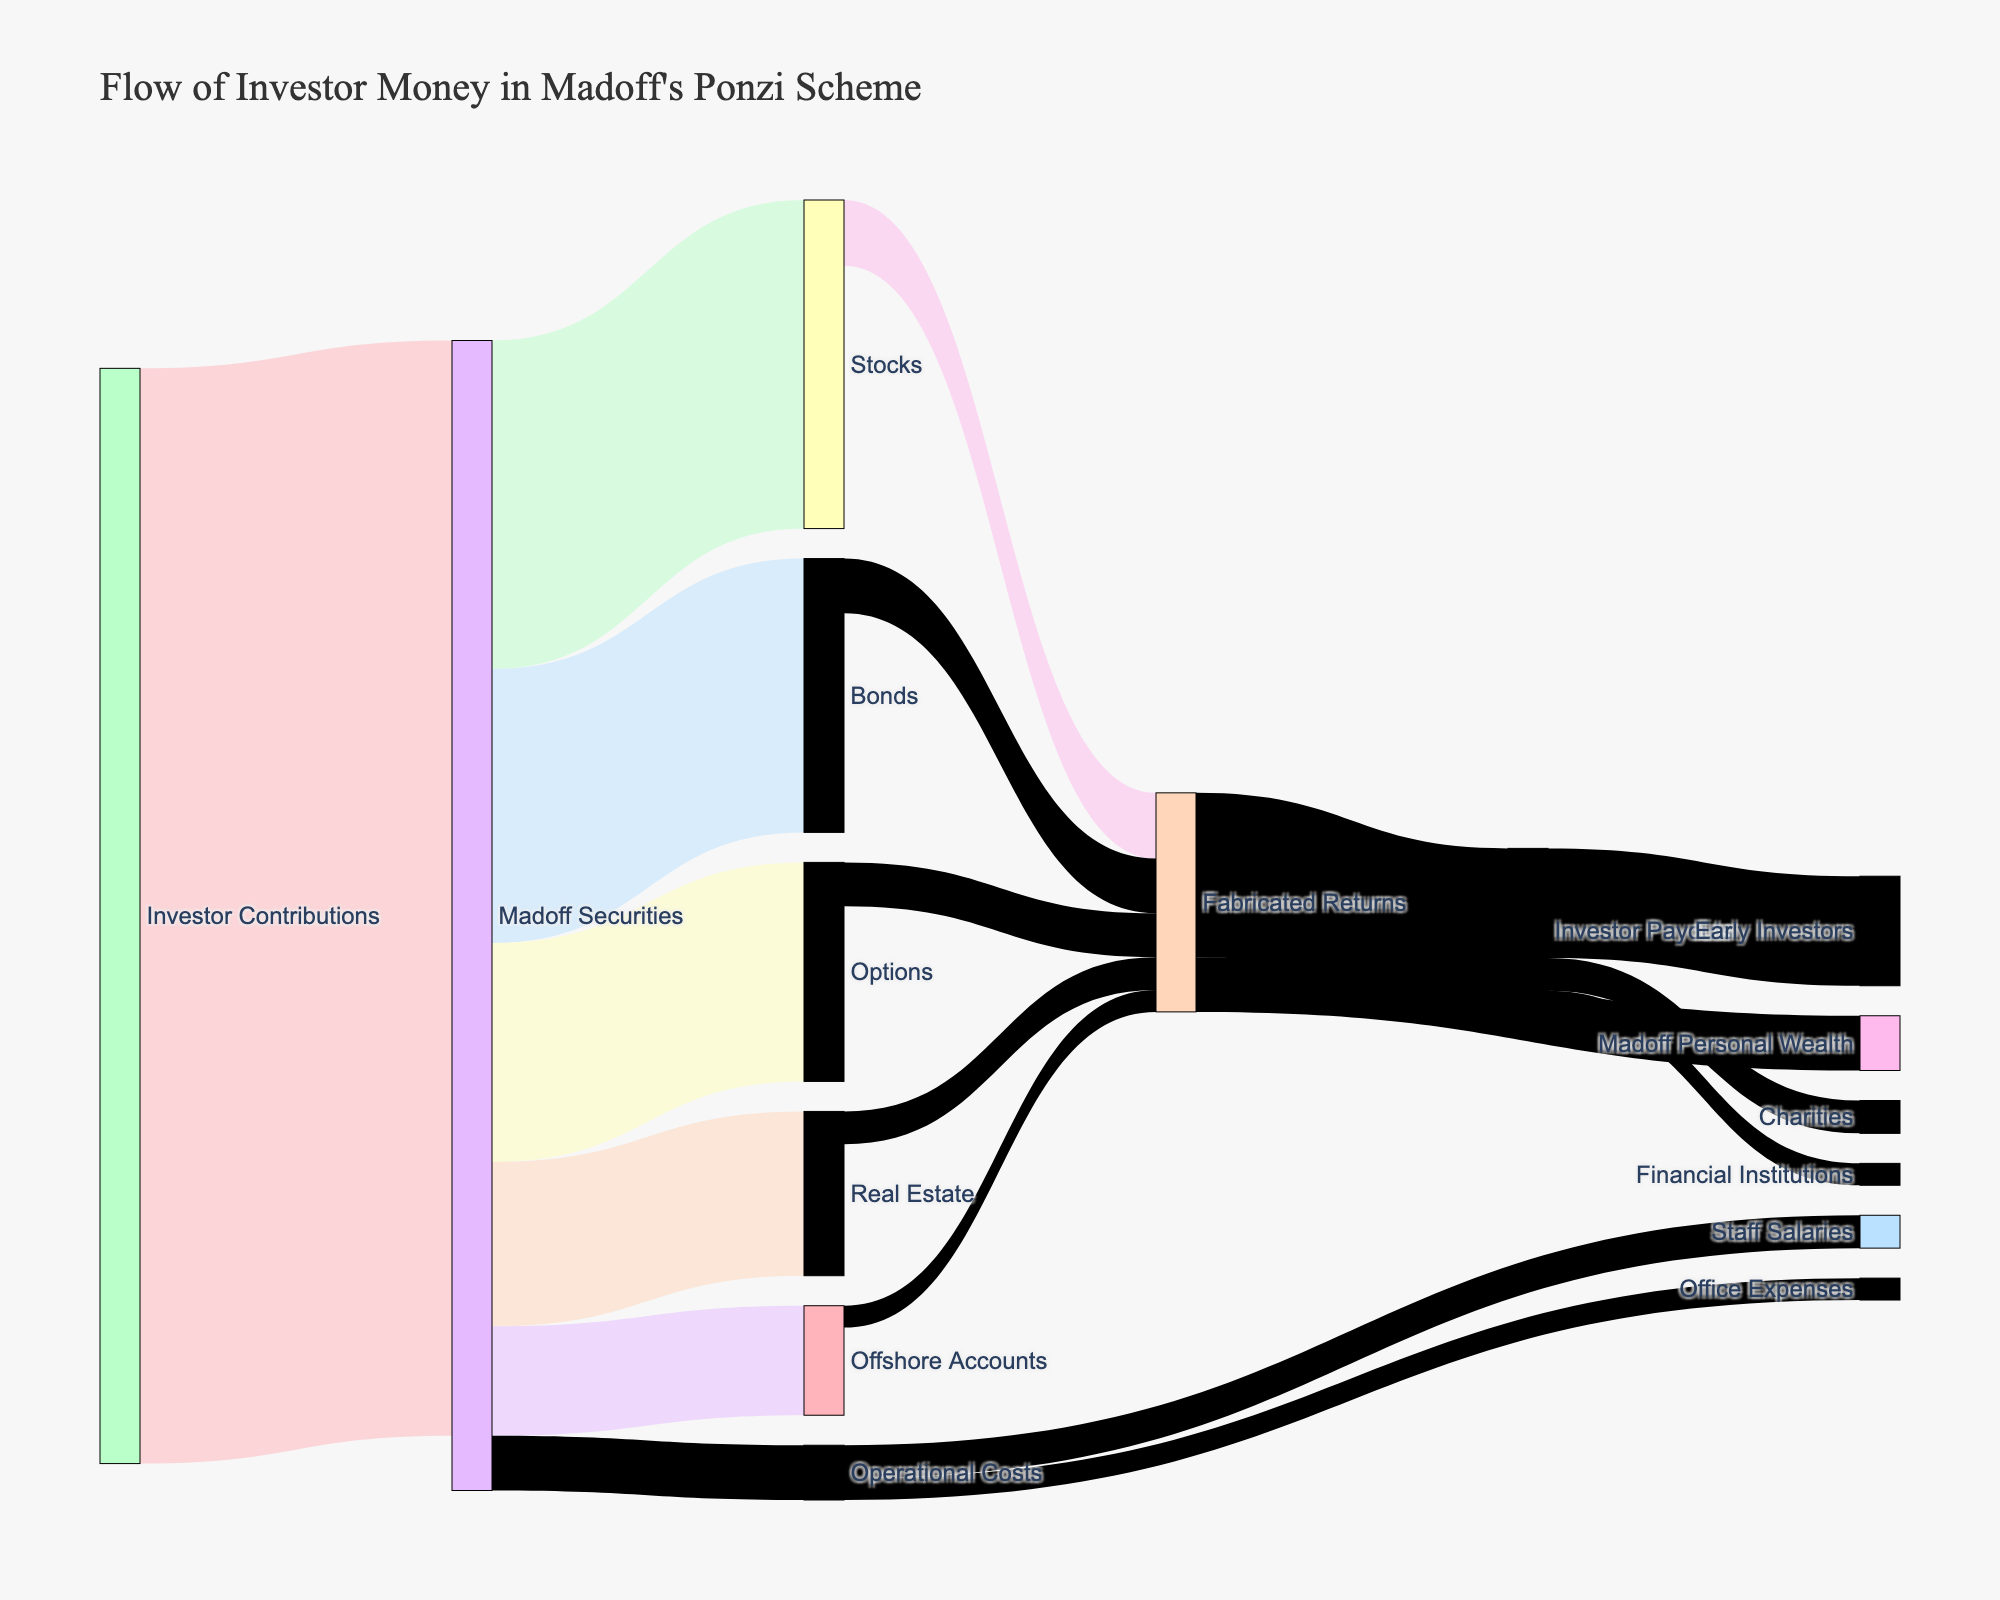What is the main title of the diagram? The main title is typically located at the top center of the figure. The title for this diagram reads "Flow of Investor Money in Madoff's Ponzi Scheme."
Answer: Flow of Investor Money in Madoff's Ponzi Scheme How many main categories are involved in the flow from 'Madoff Securities'? Observe the Sankey diagram, identifying the lines flowing out from 'Madoff Securities.' Count the distinct categories to which the money flows. There are five main categories: Stocks, Bonds, Options, Real Estate, and Offshore Accounts.
Answer: 5 How much money did 'Madoff Securities' allocate to 'Bonds'? Locate the line connecting 'Madoff Securities' to 'Bonds.' The value displayed next to the line indicates how much money was allocated. This value is 2500.
Answer: 2500 What is the total amount of money produced as 'Fabricated Returns'? Sum up the values directed towards 'Fabricated Returns' from Stocks, Bonds, Options, Real Estate, and Offshore Accounts. This sums to 2000 (600 + 500 + 400 + 300 + 200).
Answer: 2000 Which category receives the most significant portion of the 'Investor Payouts'? Look at the lines emerging from 'Investor Payouts' and compare their values. The largest value, 1000, goes to Early Investors.
Answer: Early Investors Out of 'Fabricated Returns,' which path receives the least amount of money? Observe the lines from 'Fabricated Returns' and compare their values. The smallest amount, 500, goes to Madoff Personal Wealth.
Answer: Madoff Personal Wealth How do 'Operational Costs' divide their expenses? Track the lines extending from 'Operational Costs.' They split into Staff Salaries and Office Expenses, with values of 300 and 200, respectively.
Answer: Staff Salaries and Office Expenses What's the difference in the amount directed toward 'Stocks' and 'Options' from 'Madoff Securities'? Find the values for amounts directed to Stocks and Options from 'Madoff Securities,' which are 3000 and 2000, respectively. The difference is 1000 (3000 - 2000).
Answer: 1000 Which category receives more money from 'Fabricated Returns,' Early Investors or Charities? Compare the values from 'Fabricated Returns' directed to Early Investors (1000) and Charities (300). Early Investors receive more.
Answer: Early Investors 